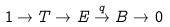<formula> <loc_0><loc_0><loc_500><loc_500>1 \rightarrow T \rightarrow E \stackrel { q } { \rightarrow } B \rightarrow 0</formula> 